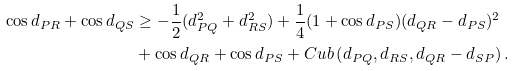<formula> <loc_0><loc_0><loc_500><loc_500>\cos d _ { P R } + \cos d _ { Q S } & \geq - \frac { 1 } { 2 } ( d _ { P Q } ^ { 2 } + d _ { R S } ^ { 2 } ) + \frac { 1 } { 4 } ( 1 + \cos d _ { P S } ) ( d _ { Q R } - d _ { P S } ) ^ { 2 } \\ & + \cos d _ { Q R } + \cos d _ { P S } + C u b \left ( d _ { P Q } , d _ { R S } , d _ { Q R } - d _ { S P } \right ) .</formula> 